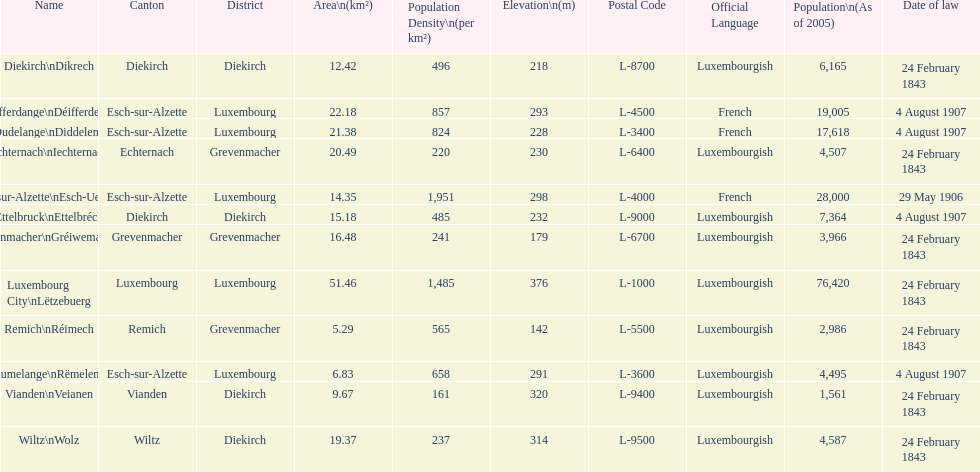Which canton falls under the date of law of 24 february 1843 and has a population of 3,966? Grevenmacher. 